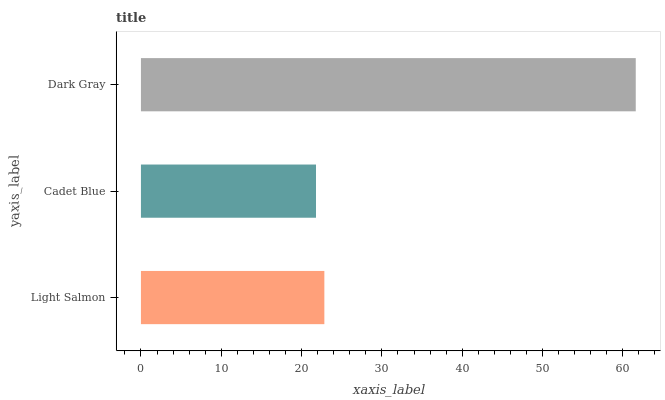Is Cadet Blue the minimum?
Answer yes or no. Yes. Is Dark Gray the maximum?
Answer yes or no. Yes. Is Dark Gray the minimum?
Answer yes or no. No. Is Cadet Blue the maximum?
Answer yes or no. No. Is Dark Gray greater than Cadet Blue?
Answer yes or no. Yes. Is Cadet Blue less than Dark Gray?
Answer yes or no. Yes. Is Cadet Blue greater than Dark Gray?
Answer yes or no. No. Is Dark Gray less than Cadet Blue?
Answer yes or no. No. Is Light Salmon the high median?
Answer yes or no. Yes. Is Light Salmon the low median?
Answer yes or no. Yes. Is Dark Gray the high median?
Answer yes or no. No. Is Dark Gray the low median?
Answer yes or no. No. 